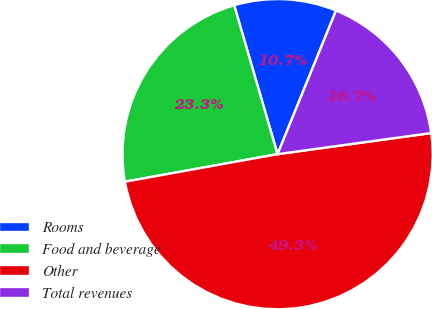<chart> <loc_0><loc_0><loc_500><loc_500><pie_chart><fcel>Rooms<fcel>Food and beverage<fcel>Other<fcel>Total revenues<nl><fcel>10.67%<fcel>23.33%<fcel>49.33%<fcel>16.67%<nl></chart> 